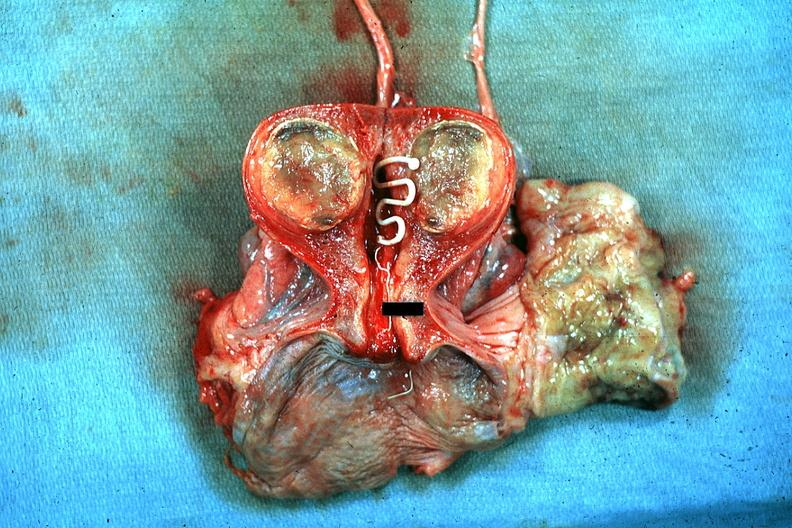where does this belong to?
Answer the question using a single word or phrase. Female reproductive system 